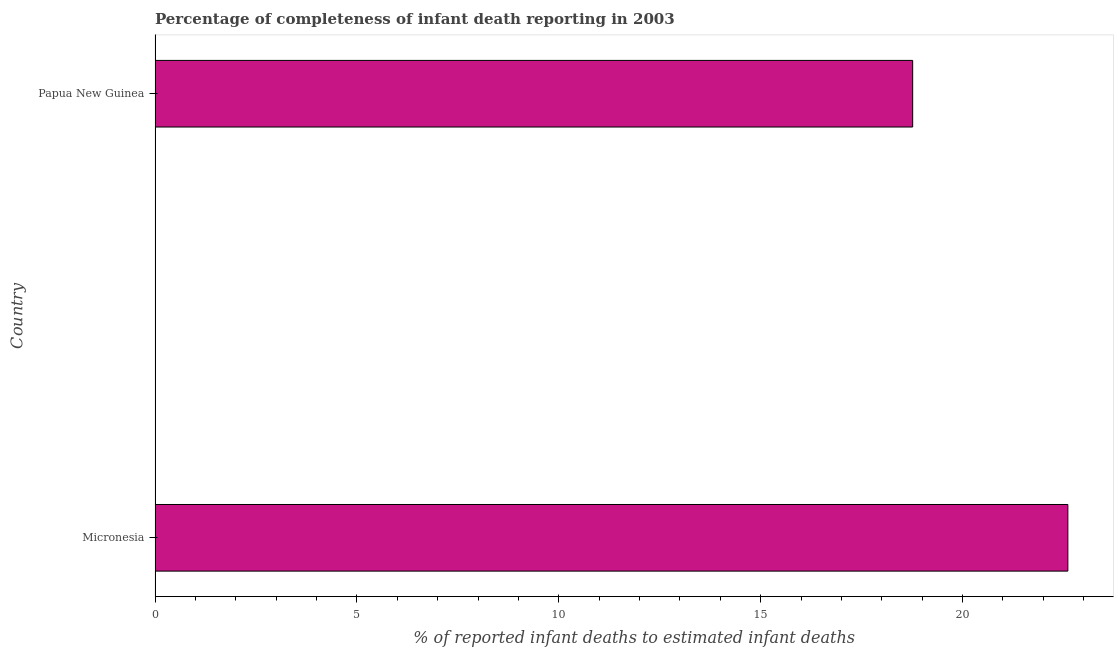Does the graph contain grids?
Keep it short and to the point. No. What is the title of the graph?
Offer a very short reply. Percentage of completeness of infant death reporting in 2003. What is the label or title of the X-axis?
Your response must be concise. % of reported infant deaths to estimated infant deaths. What is the label or title of the Y-axis?
Offer a terse response. Country. What is the completeness of infant death reporting in Micronesia?
Make the answer very short. 22.61. Across all countries, what is the maximum completeness of infant death reporting?
Give a very brief answer. 22.61. Across all countries, what is the minimum completeness of infant death reporting?
Your response must be concise. 18.77. In which country was the completeness of infant death reporting maximum?
Your answer should be very brief. Micronesia. In which country was the completeness of infant death reporting minimum?
Provide a succinct answer. Papua New Guinea. What is the sum of the completeness of infant death reporting?
Ensure brevity in your answer.  41.37. What is the difference between the completeness of infant death reporting in Micronesia and Papua New Guinea?
Provide a succinct answer. 3.84. What is the average completeness of infant death reporting per country?
Your answer should be very brief. 20.69. What is the median completeness of infant death reporting?
Your answer should be compact. 20.69. What is the ratio of the completeness of infant death reporting in Micronesia to that in Papua New Guinea?
Provide a short and direct response. 1.21. Is the completeness of infant death reporting in Micronesia less than that in Papua New Guinea?
Provide a succinct answer. No. In how many countries, is the completeness of infant death reporting greater than the average completeness of infant death reporting taken over all countries?
Provide a short and direct response. 1. Are all the bars in the graph horizontal?
Offer a terse response. Yes. What is the % of reported infant deaths to estimated infant deaths of Micronesia?
Offer a terse response. 22.61. What is the % of reported infant deaths to estimated infant deaths in Papua New Guinea?
Offer a terse response. 18.77. What is the difference between the % of reported infant deaths to estimated infant deaths in Micronesia and Papua New Guinea?
Ensure brevity in your answer.  3.84. What is the ratio of the % of reported infant deaths to estimated infant deaths in Micronesia to that in Papua New Guinea?
Give a very brief answer. 1.21. 